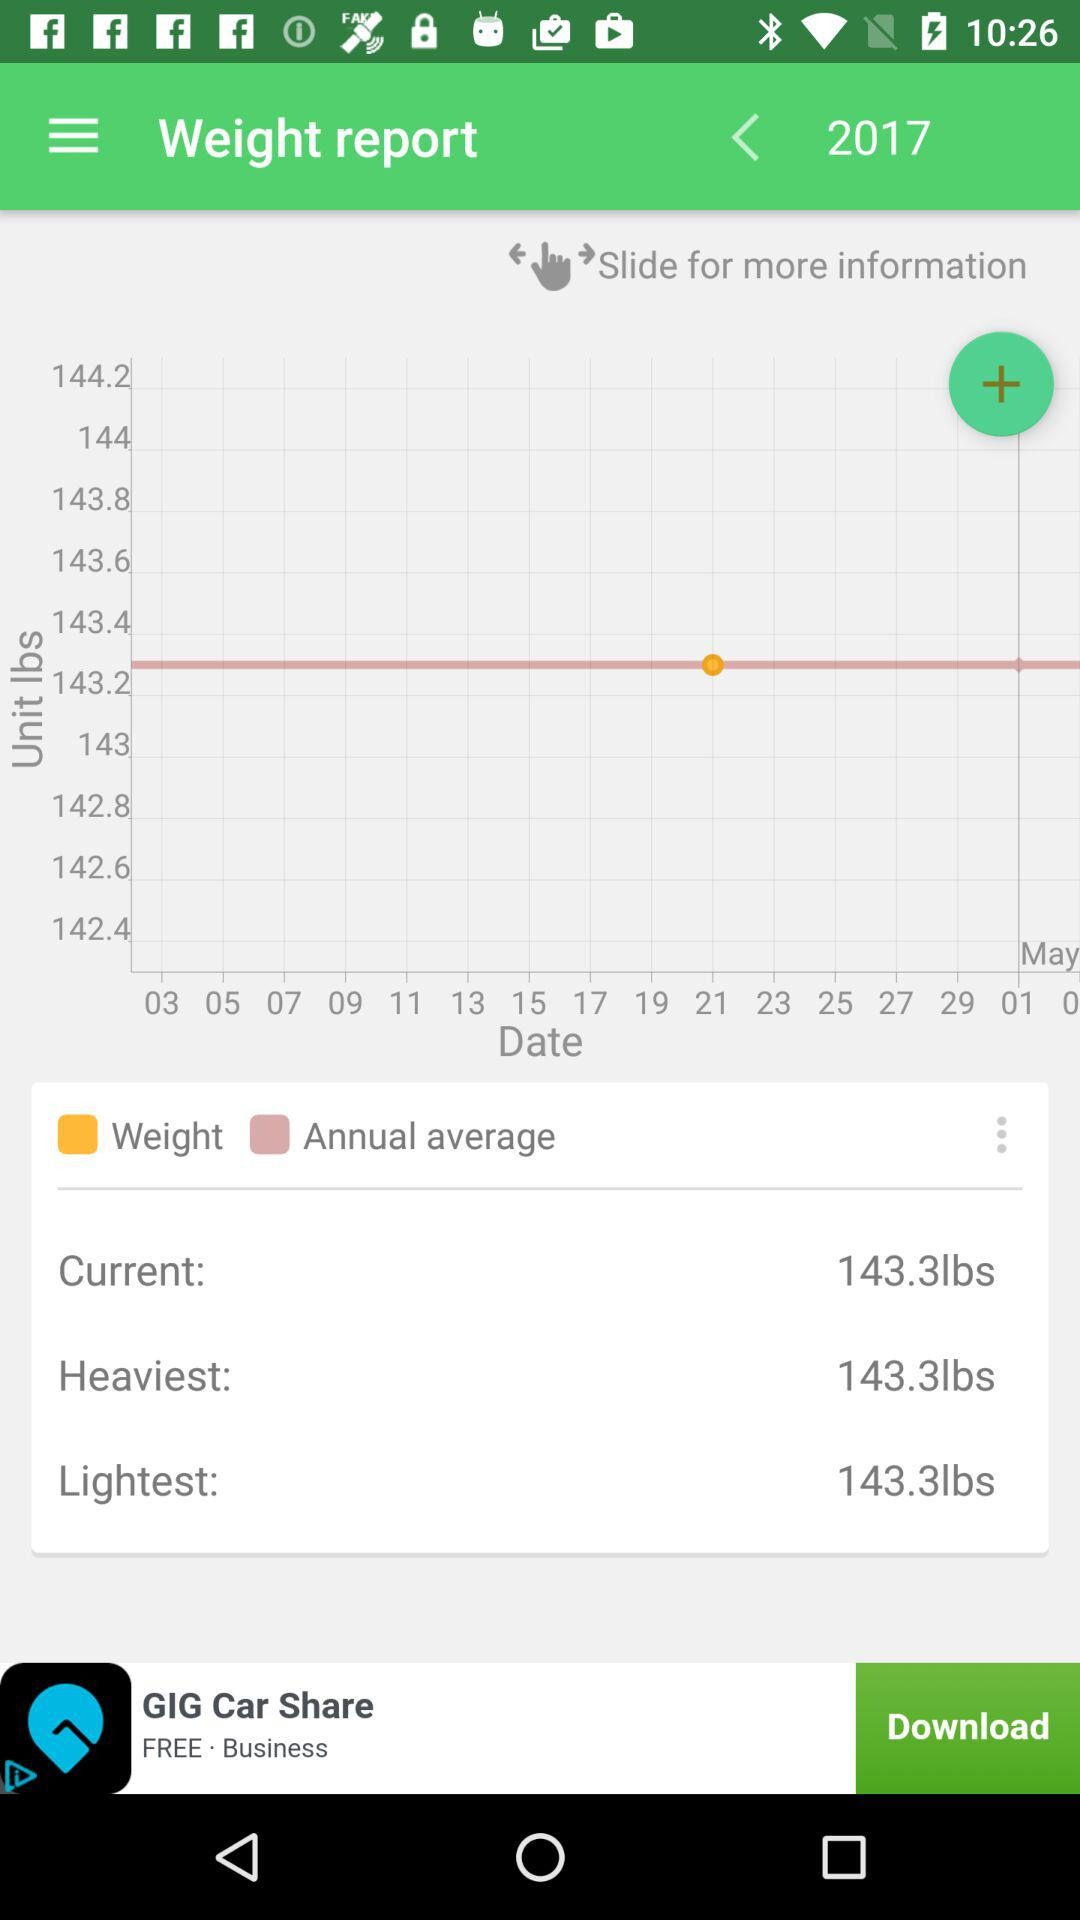What is the year of the weight report? The year is 2017. 